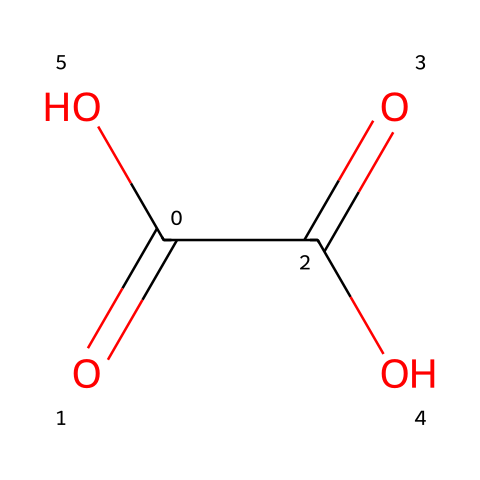What is the common name of the substance represented by this SMILES? The SMILES notation C(=O)(C(=O)O)O corresponds to a chemical that is commonly known as oxalic acid. The presence of two carbonyl groups suggests a dicarboxylic acid.
Answer: oxalic acid How many carbon atoms are present in the structure? By examining the SMILES notation, the 'C' represents carbon atoms, and there are two instances of 'C' in the structure, indicating there are two carbon atoms present.
Answer: 2 What type of functional groups are present in this molecule? The structure contains carboxylic acid groups, which can be identified from the -COOH part of the SMILES. Each carboxylic acid group denotes a -C(=O)O configuration. This indicates the presence of two carboxylic acid functional groups.
Answer: carboxylic acids How many oxygen atoms are in the structure? In the given SMILES, there are notable '-O' and '=O' symbols which represent oxygen atoms. Counting them, there are four oxygen atoms overall in the structure.
Answer: 4 What is the acidity of this compound likely high? The molecule contains two carboxylic acid functional groups, which would contribute to its acidic nature. The hydrogen atoms bonded to the oxygen in these groups can be easily released as protons (H+), indicating a high acidity.
Answer: high Does this acid show any potential use in cleaning metal artifacts? Yes, oxalic acid is primarily known for its effectiveness in removing rust and stains from metal surfaces, making it useful for cleaning metal artifacts. The two carboxylic groups help chelate metal ions, facilitating this cleaning action.
Answer: yes 